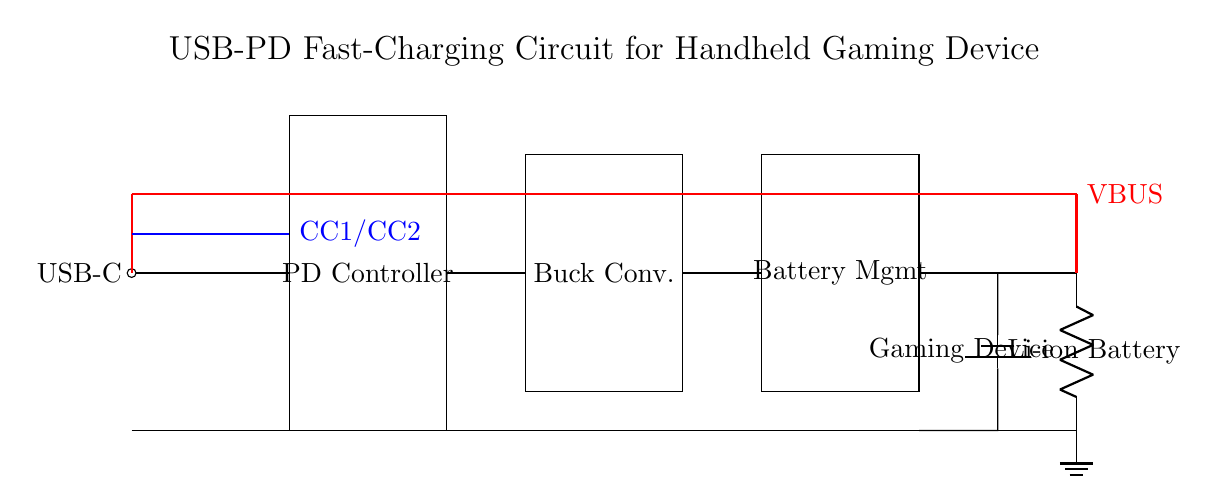What is the voltage of this circuit? The circuit is designed to handle USB power delivery standards, which typically operate at 5V, 9V, 15V, or 20V. Given that the circuit provides VBUS and the connection to the USB-C port indicates that it is designed to deliver power, we can conclude that the voltage level here is likely one of the standard USB PD voltages. For simplicity, we can state the minimum voltage supplied, which is 5V.
Answer: 5V What component manages battery charging? The Battery Management IC (Battery Mgmt) is specifically designed to oversee the charging of the battery, ensuring safe charging and managing battery health. It regulates the voltage and current going to the battery from the buck converter and manages the battery's state to prevent overcharging.
Answer: Battery Management IC How many main components are in the circuit? The main components visible in the circuit include the USB-C connector, PD controller, buck converter, battery management IC, battery, and gaming device load. By counting these distinct elements, we find that there are five main components.
Answer: Five What is the role of the Buck Converter? The Buck Converter is used to step down the voltage from a higher level to a lower usable voltage for the gaming device. It efficiently converts the input voltage (from the PD controller) to the required output voltage while supplying the appropriate current needed. This is essential for fast-charging applications.
Answer: Step down voltage What is connected to the VBUS? The VBUS is connected throughout the circuit, supplying power from the USB-C source to various components such as the PD Controller, Buck Converter, and finally to the Battery Management IC. It acts as the main power line delivering energy to the components that support the fast-charging functionality.
Answer: PD Controller, Buck Converter, Battery Management IC What type of load is indicated in the circuit? The circuit specifies a "Gaming Device" as the load, which indicates that this circuit is designed specifically to power or charge a handheld gaming device. This designation is important as it tells us the purpose of the entire circuit and the type of current and voltage it needs to supply.
Answer: Gaming Device 